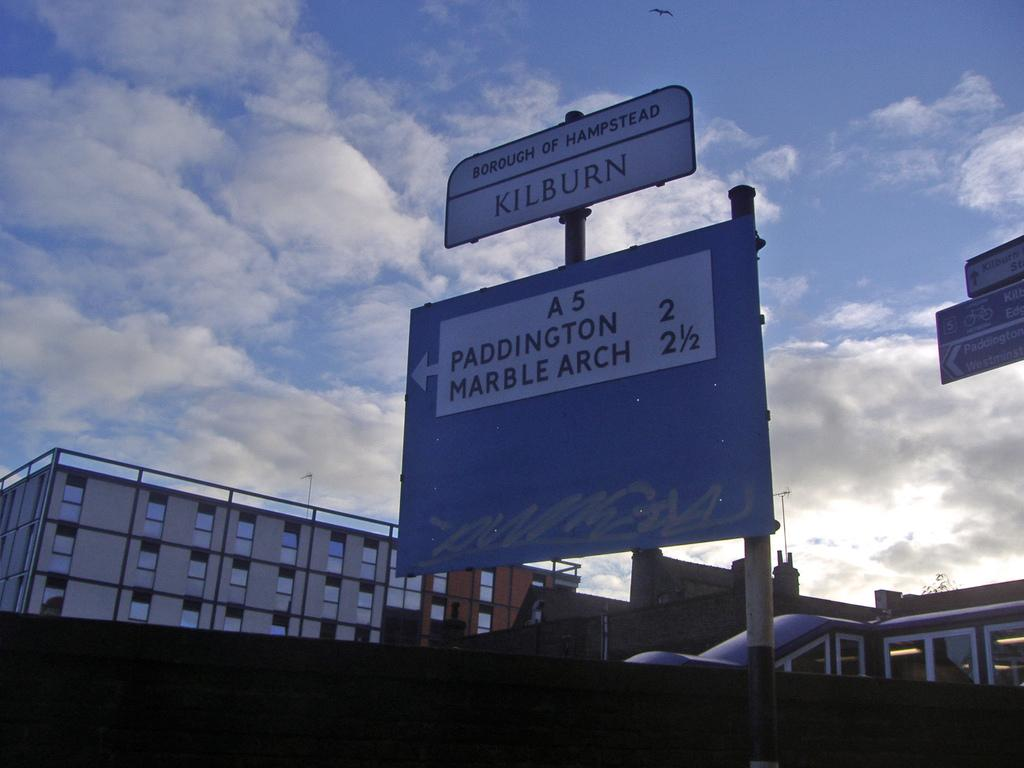<image>
Create a compact narrative representing the image presented. A large outdoor sign that reads Borough of Hampstead. 